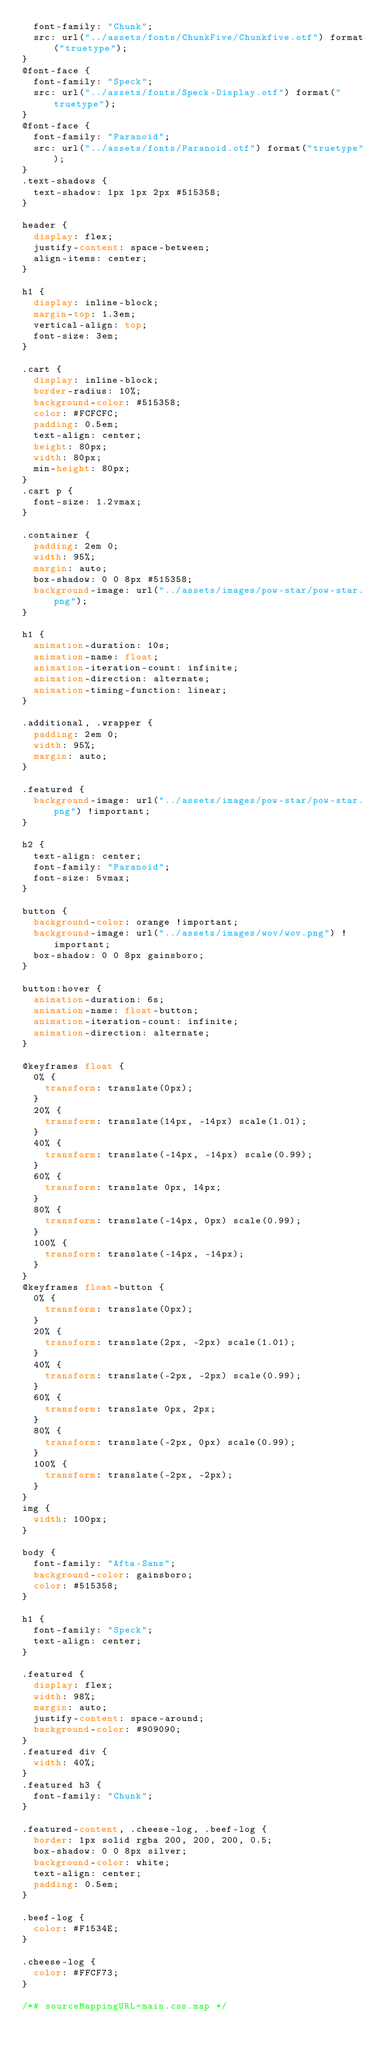Convert code to text. <code><loc_0><loc_0><loc_500><loc_500><_CSS_>  font-family: "Chunk";
  src: url("../assets/fonts/ChunkFive/Chunkfive.otf") format("truetype");
}
@font-face {
  font-family: "Speck";
  src: url("../assets/fonts/Speck-Display.otf") format("truetype");
}
@font-face {
  font-family: "Paranoid";
  src: url("../assets/fonts/Paranoid.otf") format("truetype");
}
.text-shadows {
  text-shadow: 1px 1px 2px #515358;
}

header {
  display: flex;
  justify-content: space-between;
  align-items: center;
}

h1 {
  display: inline-block;
  margin-top: 1.3em;
  vertical-align: top;
  font-size: 3em;
}

.cart {
  display: inline-block;
  border-radius: 10%;
  background-color: #515358;
  color: #FCFCFC;
  padding: 0.5em;
  text-align: center;
  height: 80px;
  width: 80px;
  min-height: 80px;
}
.cart p {
  font-size: 1.2vmax;
}

.container {
  padding: 2em 0;
  width: 95%;
  margin: auto;
  box-shadow: 0 0 8px #515358;
  background-image: url("../assets/images/pow-star/pow-star.png");
}

h1 {
  animation-duration: 10s;
  animation-name: float;
  animation-iteration-count: infinite;
  animation-direction: alternate;
  animation-timing-function: linear;
}

.additional, .wrapper {
  padding: 2em 0;
  width: 95%;
  margin: auto;
}

.featured {
  background-image: url("../assets/images/pow-star/pow-star.png") !important;
}

h2 {
  text-align: center;
  font-family: "Paranoid";
  font-size: 5vmax;
}

button {
  background-color: orange !important;
  background-image: url("../assets/images/wov/wov.png") !important;
  box-shadow: 0 0 8px gainsboro;
}

button:hover {
  animation-duration: 6s;
  animation-name: float-button;
  animation-iteration-count: infinite;
  animation-direction: alternate;
}

@keyframes float {
  0% {
    transform: translate(0px);
  }
  20% {
    transform: translate(14px, -14px) scale(1.01);
  }
  40% {
    transform: translate(-14px, -14px) scale(0.99);
  }
  60% {
    transform: translate 0px, 14px;
  }
  80% {
    transform: translate(-14px, 0px) scale(0.99);
  }
  100% {
    transform: translate(-14px, -14px);
  }
}
@keyframes float-button {
  0% {
    transform: translate(0px);
  }
  20% {
    transform: translate(2px, -2px) scale(1.01);
  }
  40% {
    transform: translate(-2px, -2px) scale(0.99);
  }
  60% {
    transform: translate 0px, 2px;
  }
  80% {
    transform: translate(-2px, 0px) scale(0.99);
  }
  100% {
    transform: translate(-2px, -2px);
  }
}
img {
  width: 100px;
}

body {
  font-family: "Afta-Sans";
  background-color: gainsboro;
  color: #515358;
}

h1 {
  font-family: "Speck";
  text-align: center;
}

.featured {
  display: flex;
  width: 98%;
  margin: auto;
  justify-content: space-around;
  background-color: #909090;
}
.featured div {
  width: 40%;
}
.featured h3 {
  font-family: "Chunk";
}

.featured-content, .cheese-log, .beef-log {
  border: 1px solid rgba 200, 200, 200, 0.5;
  box-shadow: 0 0 8px silver;
  background-color: white;
  text-align: center;
  padding: 0.5em;
}

.beef-log {
  color: #F1534E;
}

.cheese-log {
  color: #FFCF73;
}

/*# sourceMappingURL=main.css.map */
</code> 